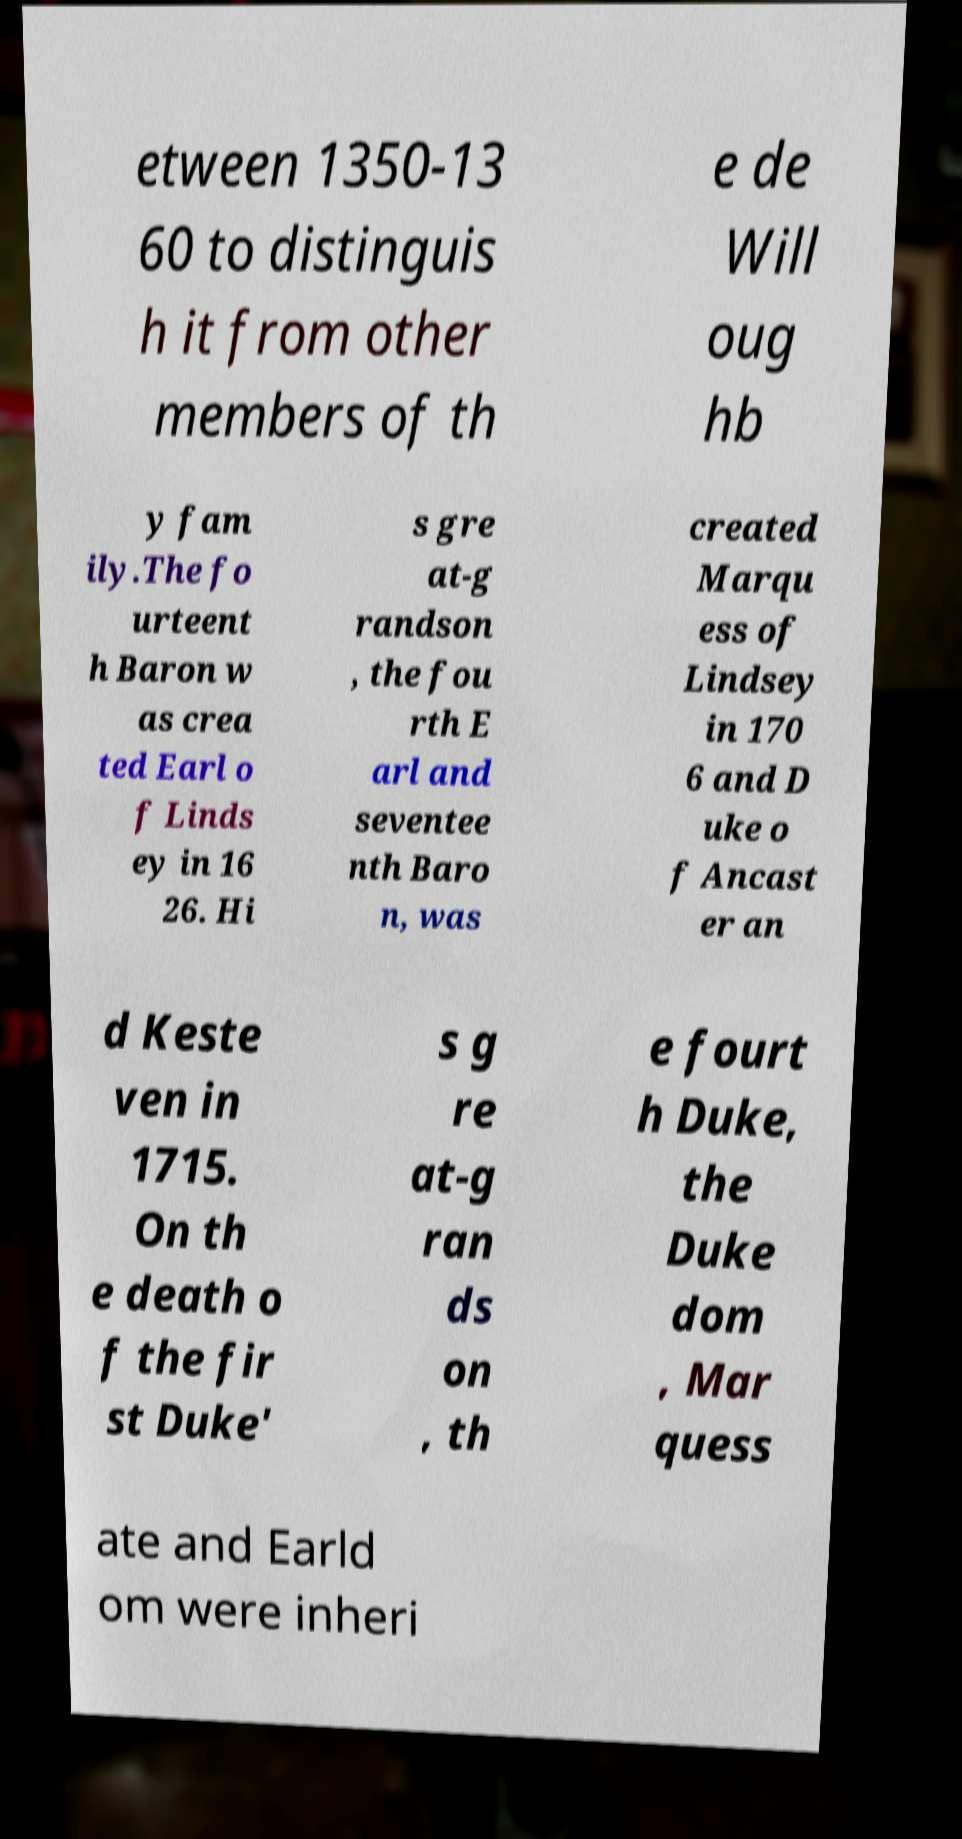There's text embedded in this image that I need extracted. Can you transcribe it verbatim? etween 1350-13 60 to distinguis h it from other members of th e de Will oug hb y fam ily.The fo urteent h Baron w as crea ted Earl o f Linds ey in 16 26. Hi s gre at-g randson , the fou rth E arl and seventee nth Baro n, was created Marqu ess of Lindsey in 170 6 and D uke o f Ancast er an d Keste ven in 1715. On th e death o f the fir st Duke' s g re at-g ran ds on , th e fourt h Duke, the Duke dom , Mar quess ate and Earld om were inheri 